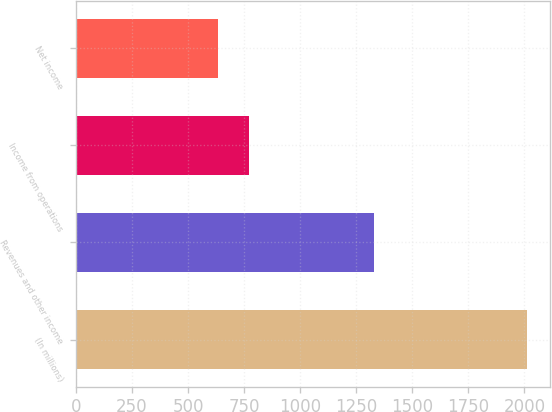Convert chart to OTSL. <chart><loc_0><loc_0><loc_500><loc_500><bar_chart><fcel>(In millions)<fcel>Revenues and other income<fcel>Income from operations<fcel>Net income<nl><fcel>2012<fcel>1330<fcel>772.7<fcel>635<nl></chart> 